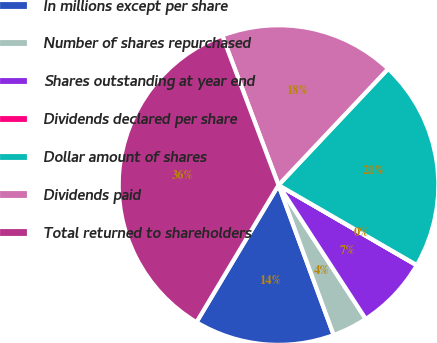Convert chart to OTSL. <chart><loc_0><loc_0><loc_500><loc_500><pie_chart><fcel>In millions except per share<fcel>Number of shares repurchased<fcel>Shares outstanding at year end<fcel>Dividends declared per share<fcel>Dollar amount of shares<fcel>Dividends paid<fcel>Total returned to shareholders<nl><fcel>14.19%<fcel>3.58%<fcel>7.44%<fcel>0.02%<fcel>21.32%<fcel>17.76%<fcel>35.69%<nl></chart> 